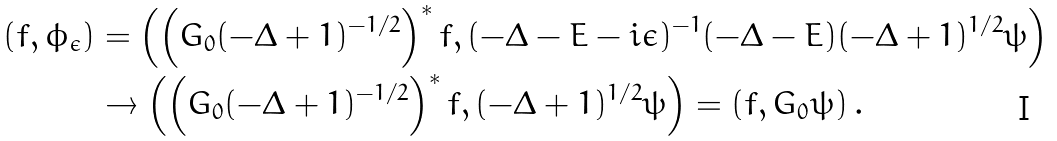<formula> <loc_0><loc_0><loc_500><loc_500>( f , \phi _ { \epsilon } ) & = \left ( \left ( G _ { 0 } ( - \Delta + 1 ) ^ { - 1 / 2 } \right ) ^ { * } f , ( - \Delta - E - i \epsilon ) ^ { - 1 } ( - \Delta - E ) ( - \Delta + 1 ) ^ { 1 / 2 } \psi \right ) \\ & \to \left ( \left ( G _ { 0 } ( - \Delta + 1 ) ^ { - 1 / 2 } \right ) ^ { * } f , ( - \Delta + 1 ) ^ { 1 / 2 } \psi \right ) = ( f , G _ { 0 } \psi ) \, .</formula> 